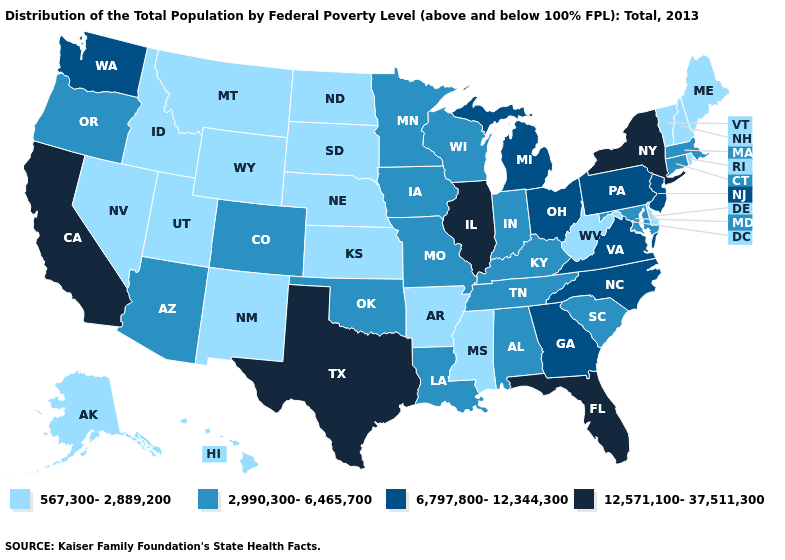Which states have the highest value in the USA?
Keep it brief. California, Florida, Illinois, New York, Texas. What is the lowest value in states that border Ohio?
Concise answer only. 567,300-2,889,200. What is the value of Illinois?
Answer briefly. 12,571,100-37,511,300. Which states have the highest value in the USA?
Answer briefly. California, Florida, Illinois, New York, Texas. Does New York have the highest value in the USA?
Concise answer only. Yes. Does the first symbol in the legend represent the smallest category?
Answer briefly. Yes. Among the states that border West Virginia , does Kentucky have the highest value?
Keep it brief. No. Which states have the highest value in the USA?
Concise answer only. California, Florida, Illinois, New York, Texas. Does Iowa have a lower value than Nebraska?
Keep it brief. No. Does the map have missing data?
Concise answer only. No. Name the states that have a value in the range 567,300-2,889,200?
Concise answer only. Alaska, Arkansas, Delaware, Hawaii, Idaho, Kansas, Maine, Mississippi, Montana, Nebraska, Nevada, New Hampshire, New Mexico, North Dakota, Rhode Island, South Dakota, Utah, Vermont, West Virginia, Wyoming. What is the lowest value in the USA?
Be succinct. 567,300-2,889,200. Does Indiana have the same value as Alabama?
Quick response, please. Yes. What is the value of New York?
Concise answer only. 12,571,100-37,511,300. What is the value of Louisiana?
Short answer required. 2,990,300-6,465,700. 